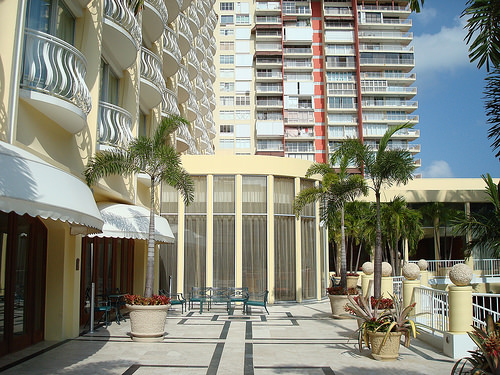<image>
Is the building in front of the tree? No. The building is not in front of the tree. The spatial positioning shows a different relationship between these objects. 